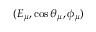Convert formula to latex. <formula><loc_0><loc_0><loc_500><loc_500>( E _ { \mu } , \cos \theta _ { \mu } , \phi _ { \mu } )</formula> 